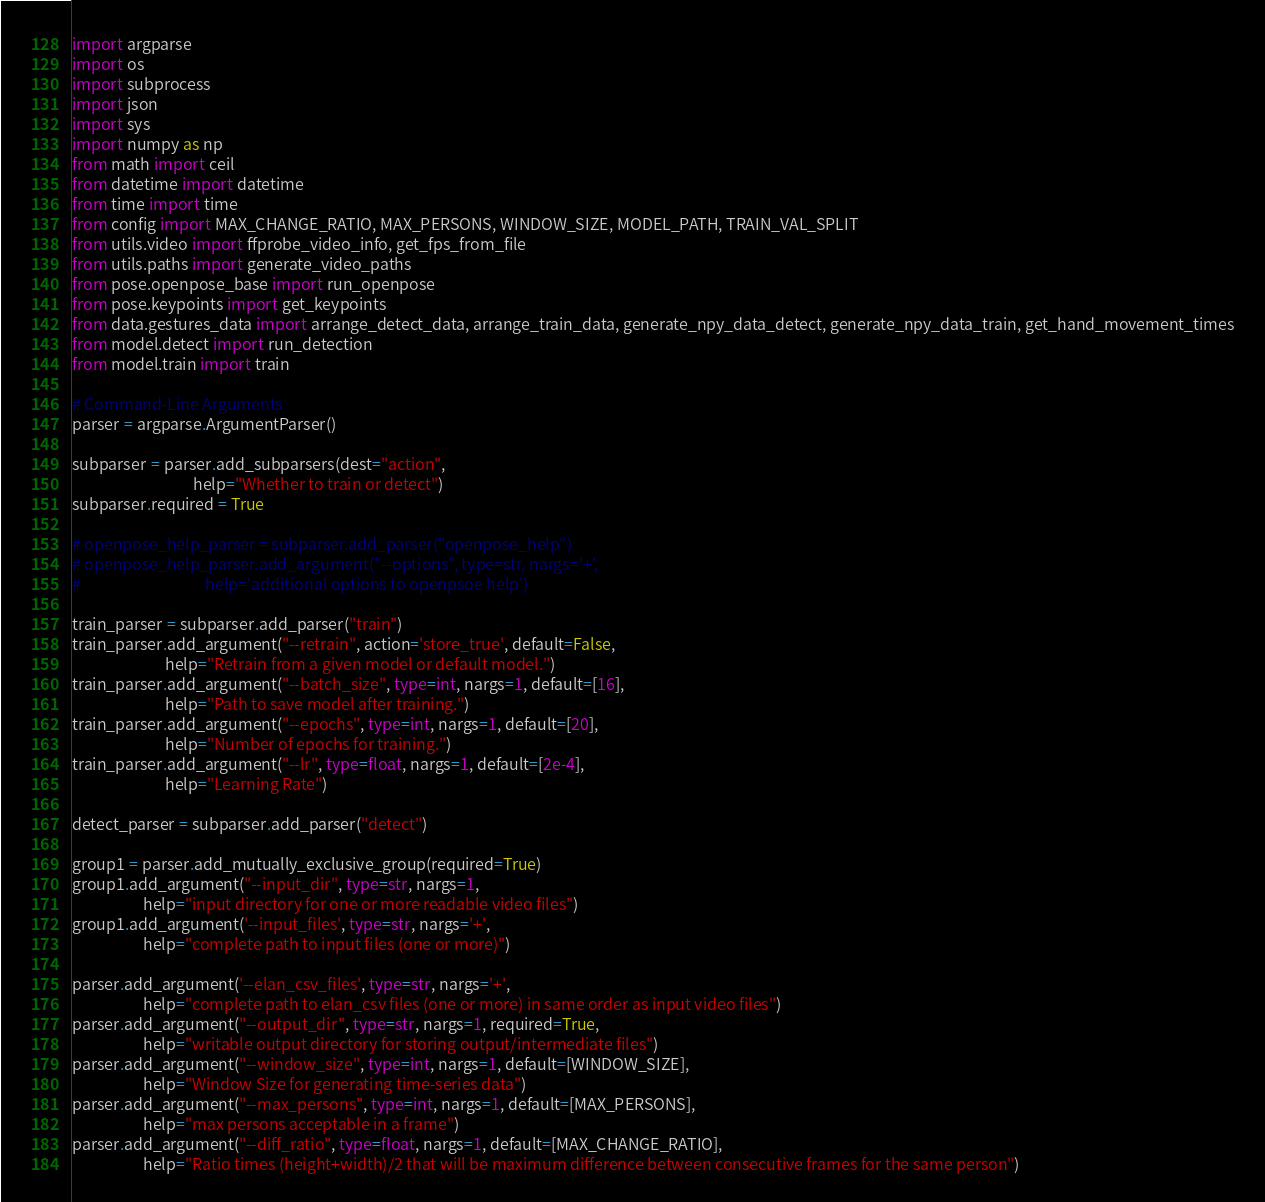Convert code to text. <code><loc_0><loc_0><loc_500><loc_500><_Python_>import argparse
import os
import subprocess
import json
import sys
import numpy as np
from math import ceil
from datetime import datetime
from time import time
from config import MAX_CHANGE_RATIO, MAX_PERSONS, WINDOW_SIZE, MODEL_PATH, TRAIN_VAL_SPLIT
from utils.video import ffprobe_video_info, get_fps_from_file
from utils.paths import generate_video_paths
from pose.openpose_base import run_openpose
from pose.keypoints import get_keypoints
from data.gestures_data import arrange_detect_data, arrange_train_data, generate_npy_data_detect, generate_npy_data_train, get_hand_movement_times
from model.detect import run_detection
from model.train import train

# Command-Line Arguments
parser = argparse.ArgumentParser()

subparser = parser.add_subparsers(dest="action",
                                  help="Whether to train or detect")
subparser.required = True

# openpose_help_parser = subparser.add_parser("openpose_help")
# openpose_help_parser.add_argument("--options", type=str, nargs='+',
#                                   help='additional options to openpsoe help')

train_parser = subparser.add_parser("train")
train_parser.add_argument("--retrain", action='store_true', default=False,
                          help="Retrain from a given model or default model.")
train_parser.add_argument("--batch_size", type=int, nargs=1, default=[16],
                          help="Path to save model after training.")
train_parser.add_argument("--epochs", type=int, nargs=1, default=[20],
                          help="Number of epochs for training.")
train_parser.add_argument("--lr", type=float, nargs=1, default=[2e-4],
                          help="Learning Rate")

detect_parser = subparser.add_parser("detect")

group1 = parser.add_mutually_exclusive_group(required=True)
group1.add_argument("--input_dir", type=str, nargs=1,
                    help="input directory for one or more readable video files")
group1.add_argument('--input_files', type=str, nargs='+',
                    help="complete path to input files (one or more)")

parser.add_argument('--elan_csv_files', type=str, nargs='+',
                    help="complete path to elan_csv files (one or more) in same order as input video files")
parser.add_argument("--output_dir", type=str, nargs=1, required=True,
                    help="writable output directory for storing output/intermediate files")
parser.add_argument("--window_size", type=int, nargs=1, default=[WINDOW_SIZE],
                    help="Window Size for generating time-series data")
parser.add_argument("--max_persons", type=int, nargs=1, default=[MAX_PERSONS],
                    help="max persons acceptable in a frame")
parser.add_argument("--diff_ratio", type=float, nargs=1, default=[MAX_CHANGE_RATIO],
                    help="Ratio times (height+width)/2 that will be maximum difference between consecutive frames for the same person")</code> 